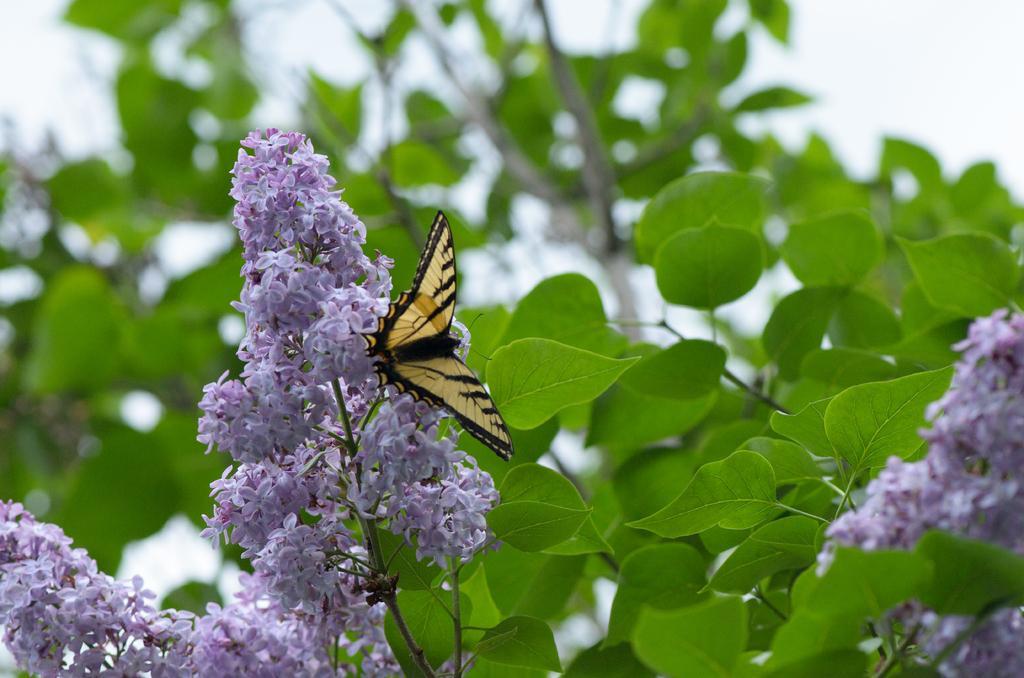Please provide a concise description of this image. In this image I can see few purple color flowers and few green color leaves. I can see the sky and the yellow and black color butterfly on the flowers. 